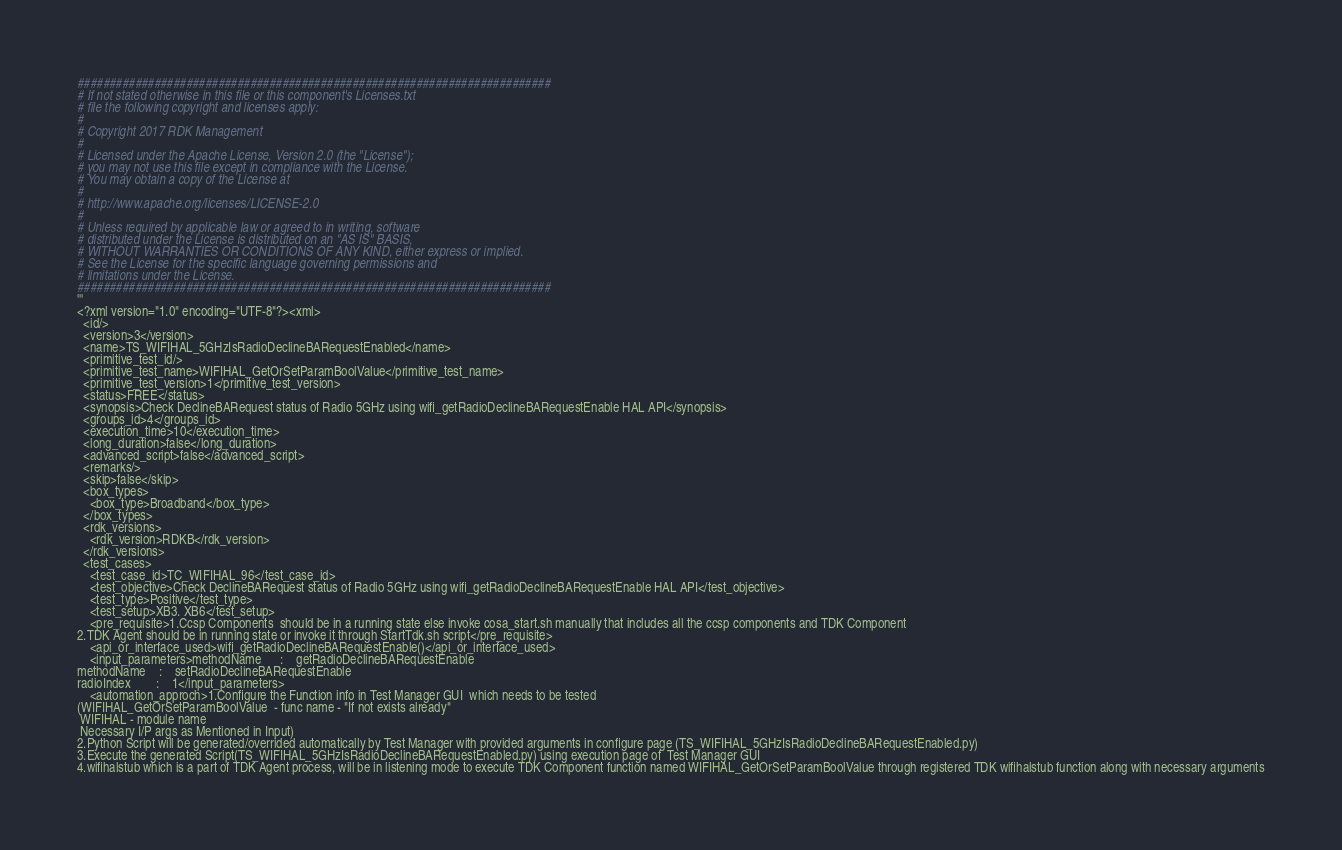<code> <loc_0><loc_0><loc_500><loc_500><_Python_>##########################################################################
# If not stated otherwise in this file or this component's Licenses.txt
# file the following copyright and licenses apply:
#
# Copyright 2017 RDK Management
#
# Licensed under the Apache License, Version 2.0 (the "License");
# you may not use this file except in compliance with the License.
# You may obtain a copy of the License at
#
# http://www.apache.org/licenses/LICENSE-2.0
#
# Unless required by applicable law or agreed to in writing, software
# distributed under the License is distributed on an "AS IS" BASIS,
# WITHOUT WARRANTIES OR CONDITIONS OF ANY KIND, either express or implied.
# See the License for the specific language governing permissions and
# limitations under the License.
##########################################################################
'''
<?xml version="1.0" encoding="UTF-8"?><xml>
  <id/>
  <version>3</version>
  <name>TS_WIFIHAL_5GHzIsRadioDeclineBARequestEnabled</name>
  <primitive_test_id/>
  <primitive_test_name>WIFIHAL_GetOrSetParamBoolValue</primitive_test_name>
  <primitive_test_version>1</primitive_test_version>
  <status>FREE</status>
  <synopsis>Check DeclineBARequest status of Radio 5GHz using wifi_getRadioDeclineBARequestEnable HAL API</synopsis>
  <groups_id>4</groups_id>
  <execution_time>10</execution_time>
  <long_duration>false</long_duration>
  <advanced_script>false</advanced_script>
  <remarks/>
  <skip>false</skip>
  <box_types>
    <box_type>Broadband</box_type>
  </box_types>
  <rdk_versions>
    <rdk_version>RDKB</rdk_version>
  </rdk_versions>
  <test_cases>
    <test_case_id>TC_WIFIHAL_96</test_case_id>
    <test_objective>Check DeclineBARequest status of Radio 5GHz using wifi_getRadioDeclineBARequestEnable HAL API</test_objective>
    <test_type>Positive</test_type>
    <test_setup>XB3. XB6</test_setup>
    <pre_requisite>1.Ccsp Components  should be in a running state else invoke cosa_start.sh manually that includes all the ccsp components and TDK Component
2.TDK Agent should be in running state or invoke it through StartTdk.sh script</pre_requisite>
    <api_or_interface_used>wifi_getRadioDeclineBARequestEnable()</api_or_interface_used>
    <input_parameters>methodName	  :    getRadioDeclineBARequestEnable
methodName	  :    setRadioDeclineBARequestEnable
radioIndex        :    1</input_parameters>
    <automation_approch>1.Configure the Function info in Test Manager GUI  which needs to be tested  
(WIFIHAL_GetOrSetParamBoolValue  - func name - "If not exists already"
 WIFIHAL - module name
 Necessary I/P args as Mentioned in Input)
2.Python Script will be generated/overrided automatically by Test Manager with provided arguments in configure page (TS_WIFIHAL_5GHzIsRadioDeclineBARequestEnabled.py)
3.Execute the generated Script(TS_WIFIHAL_5GHzIsRadioDeclineBARequestEnabled.py) using execution page of  Test Manager GUI
4.wifihalstub which is a part of TDK Agent process, will be in listening mode to execute TDK Component function named WIFIHAL_GetOrSetParamBoolValue through registered TDK wifihalstub function along with necessary arguments</code> 